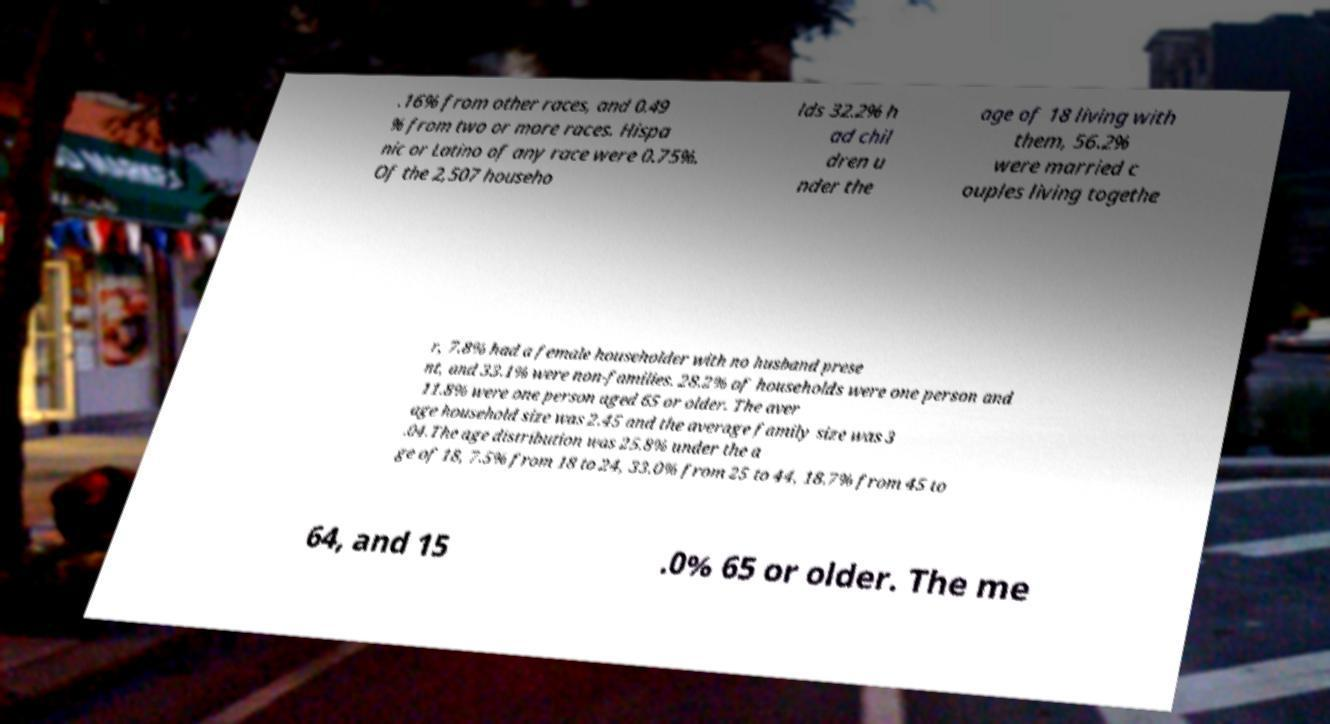There's text embedded in this image that I need extracted. Can you transcribe it verbatim? .16% from other races, and 0.49 % from two or more races. Hispa nic or Latino of any race were 0.75%. Of the 2,507 househo lds 32.2% h ad chil dren u nder the age of 18 living with them, 56.2% were married c ouples living togethe r, 7.8% had a female householder with no husband prese nt, and 33.1% were non-families. 28.2% of households were one person and 11.8% were one person aged 65 or older. The aver age household size was 2.45 and the average family size was 3 .04.The age distribution was 25.8% under the a ge of 18, 7.5% from 18 to 24, 33.0% from 25 to 44, 18.7% from 45 to 64, and 15 .0% 65 or older. The me 